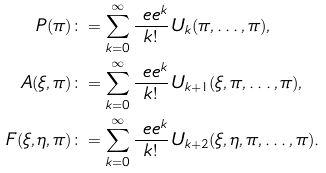Convert formula to latex. <formula><loc_0><loc_0><loc_500><loc_500>P ( \pi ) & \colon = \sum _ { k = 0 } ^ { \infty } \frac { \ e e ^ { k } } { k ! } \, U _ { k } ( \pi , \dots , \pi ) , \\ A ( \xi , \pi ) & \colon = \sum _ { k = 0 } ^ { \infty } \frac { \ e e ^ { k } } { k ! } \, U _ { k + 1 } ( \xi , \pi , \dots , \pi ) , \\ F ( \xi , \eta , \pi ) & \colon = \sum _ { k = 0 } ^ { \infty } \frac { \ e e ^ { k } } { k ! } \, U _ { k + 2 } ( \xi , \eta , \pi , \dots , \pi ) .</formula> 